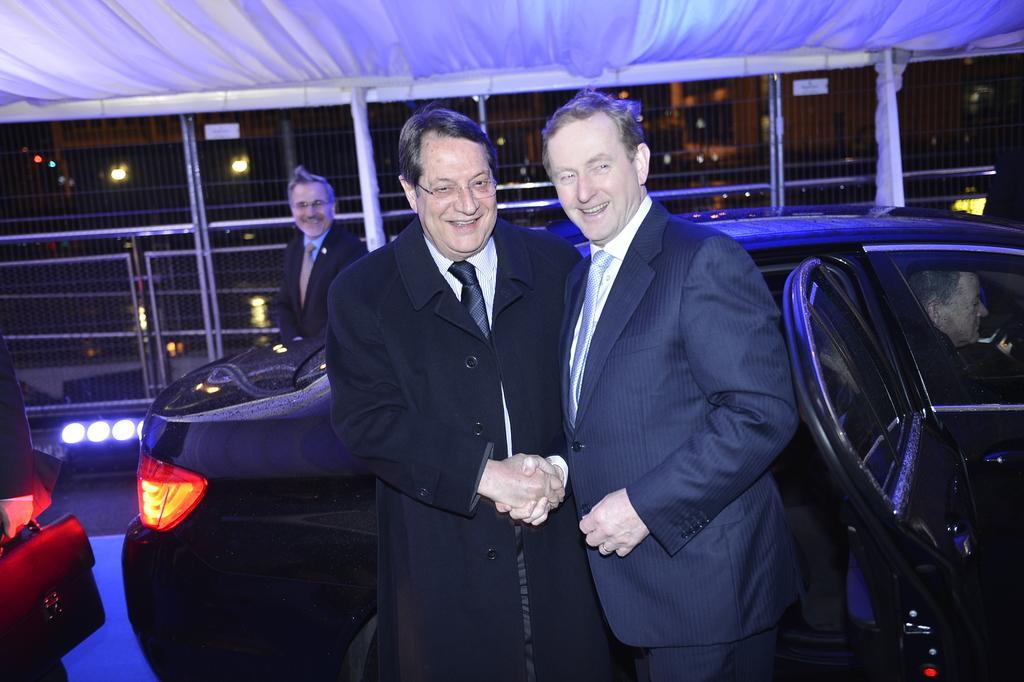In one or two sentences, can you explain what this image depicts? This is image is taken under a tent. There are three persons standing. They are wearing suit and tie. There is a car behind these two persons in which a person is sitting in it. Background of image there is a fence having few lights. 